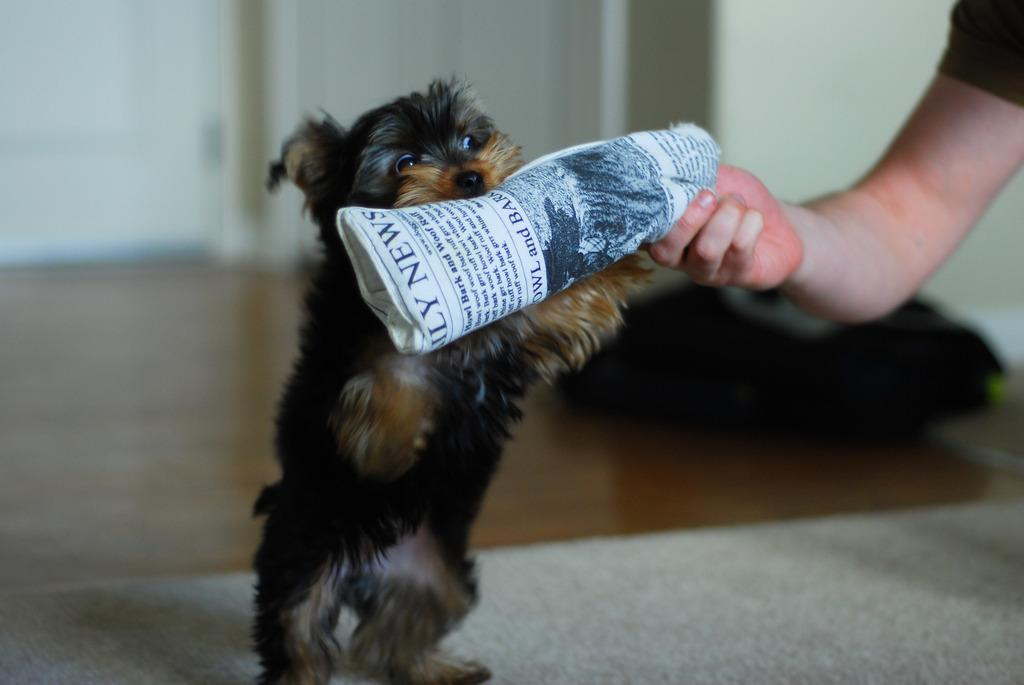What type of animal is in the image? There is a dog in the image. What is the dog doing in the image? The dog is standing and holding a newspaper in its mouth. Who else is present in the image? There is a person in the image. What is the person doing in the image? The person is holding a newspaper in their hand. How does the zephyr affect the distribution of newspapers in the image? There is no mention of a zephyr or any wind in the image, so it cannot be determined how it would affect the distribution of newspapers. 